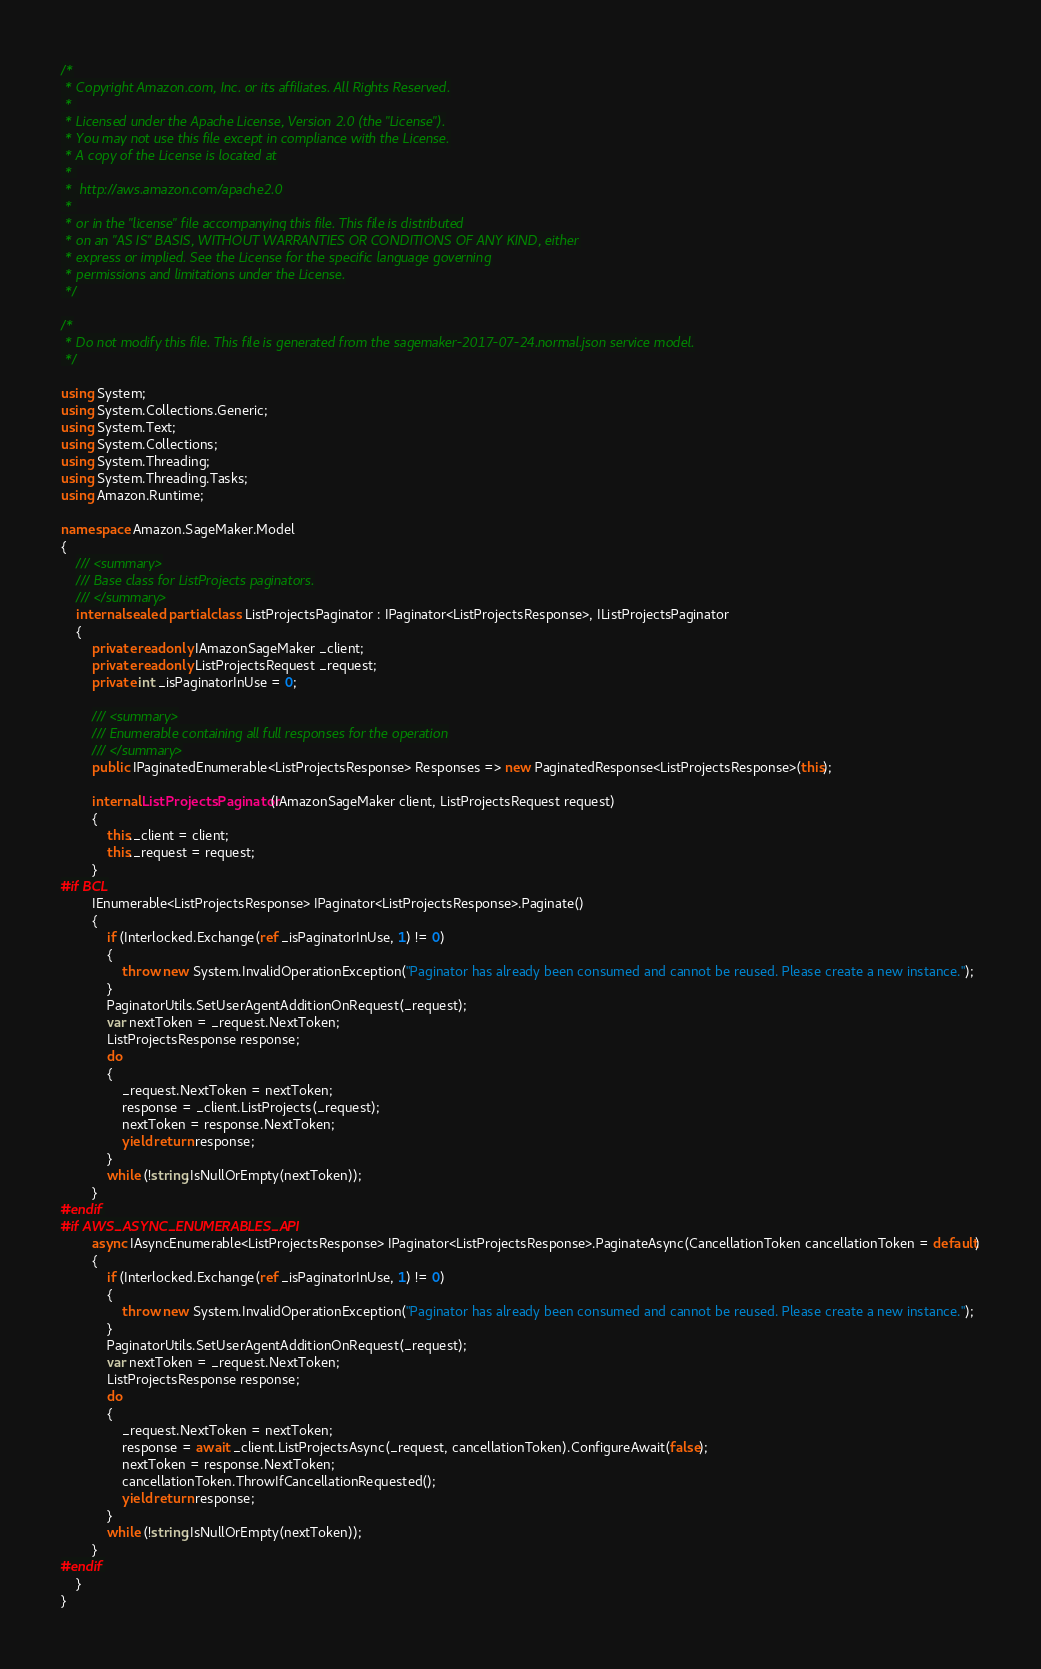<code> <loc_0><loc_0><loc_500><loc_500><_C#_>/*
 * Copyright Amazon.com, Inc. or its affiliates. All Rights Reserved.
 * 
 * Licensed under the Apache License, Version 2.0 (the "License").
 * You may not use this file except in compliance with the License.
 * A copy of the License is located at
 * 
 *  http://aws.amazon.com/apache2.0
 * 
 * or in the "license" file accompanying this file. This file is distributed
 * on an "AS IS" BASIS, WITHOUT WARRANTIES OR CONDITIONS OF ANY KIND, either
 * express or implied. See the License for the specific language governing
 * permissions and limitations under the License.
 */

/*
 * Do not modify this file. This file is generated from the sagemaker-2017-07-24.normal.json service model.
 */

using System;
using System.Collections.Generic;
using System.Text;
using System.Collections;
using System.Threading;
using System.Threading.Tasks;
using Amazon.Runtime;
 
namespace Amazon.SageMaker.Model
{
    /// <summary>
    /// Base class for ListProjects paginators.
    /// </summary>
    internal sealed partial class ListProjectsPaginator : IPaginator<ListProjectsResponse>, IListProjectsPaginator
    {
        private readonly IAmazonSageMaker _client;
        private readonly ListProjectsRequest _request;
        private int _isPaginatorInUse = 0;
        
        /// <summary>
        /// Enumerable containing all full responses for the operation
        /// </summary>
        public IPaginatedEnumerable<ListProjectsResponse> Responses => new PaginatedResponse<ListProjectsResponse>(this);

        internal ListProjectsPaginator(IAmazonSageMaker client, ListProjectsRequest request)
        {
            this._client = client;
            this._request = request;
        }
#if BCL
        IEnumerable<ListProjectsResponse> IPaginator<ListProjectsResponse>.Paginate()
        {
            if (Interlocked.Exchange(ref _isPaginatorInUse, 1) != 0)
            {
                throw new System.InvalidOperationException("Paginator has already been consumed and cannot be reused. Please create a new instance.");
            }
            PaginatorUtils.SetUserAgentAdditionOnRequest(_request);
            var nextToken = _request.NextToken;
            ListProjectsResponse response;
            do
            {
                _request.NextToken = nextToken;
                response = _client.ListProjects(_request);
                nextToken = response.NextToken;
                yield return response;
            }
            while (!string.IsNullOrEmpty(nextToken));
        }
#endif
#if AWS_ASYNC_ENUMERABLES_API
        async IAsyncEnumerable<ListProjectsResponse> IPaginator<ListProjectsResponse>.PaginateAsync(CancellationToken cancellationToken = default)
        {
            if (Interlocked.Exchange(ref _isPaginatorInUse, 1) != 0)
            {
                throw new System.InvalidOperationException("Paginator has already been consumed and cannot be reused. Please create a new instance.");
            }
            PaginatorUtils.SetUserAgentAdditionOnRequest(_request);
            var nextToken = _request.NextToken;
            ListProjectsResponse response;
            do
            {
                _request.NextToken = nextToken;
                response = await _client.ListProjectsAsync(_request, cancellationToken).ConfigureAwait(false);
                nextToken = response.NextToken;
                cancellationToken.ThrowIfCancellationRequested();
                yield return response;
            }
            while (!string.IsNullOrEmpty(nextToken));
        }
#endif
    }
}</code> 